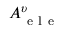<formula> <loc_0><loc_0><loc_500><loc_500>A _ { e l e } ^ { \upsilon }</formula> 